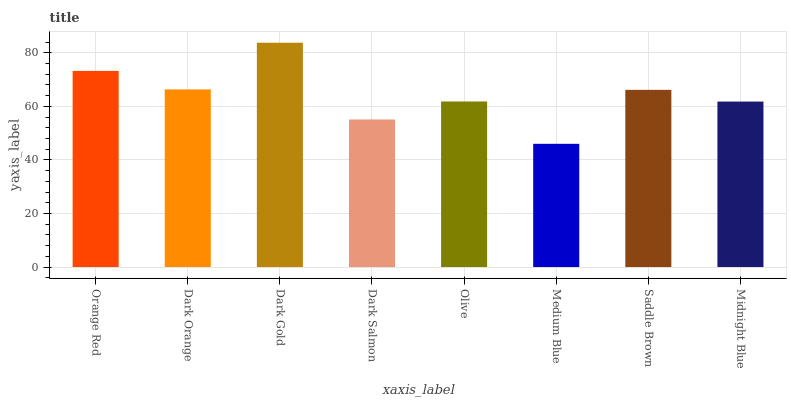Is Medium Blue the minimum?
Answer yes or no. Yes. Is Dark Gold the maximum?
Answer yes or no. Yes. Is Dark Orange the minimum?
Answer yes or no. No. Is Dark Orange the maximum?
Answer yes or no. No. Is Orange Red greater than Dark Orange?
Answer yes or no. Yes. Is Dark Orange less than Orange Red?
Answer yes or no. Yes. Is Dark Orange greater than Orange Red?
Answer yes or no. No. Is Orange Red less than Dark Orange?
Answer yes or no. No. Is Saddle Brown the high median?
Answer yes or no. Yes. Is Olive the low median?
Answer yes or no. Yes. Is Dark Gold the high median?
Answer yes or no. No. Is Midnight Blue the low median?
Answer yes or no. No. 